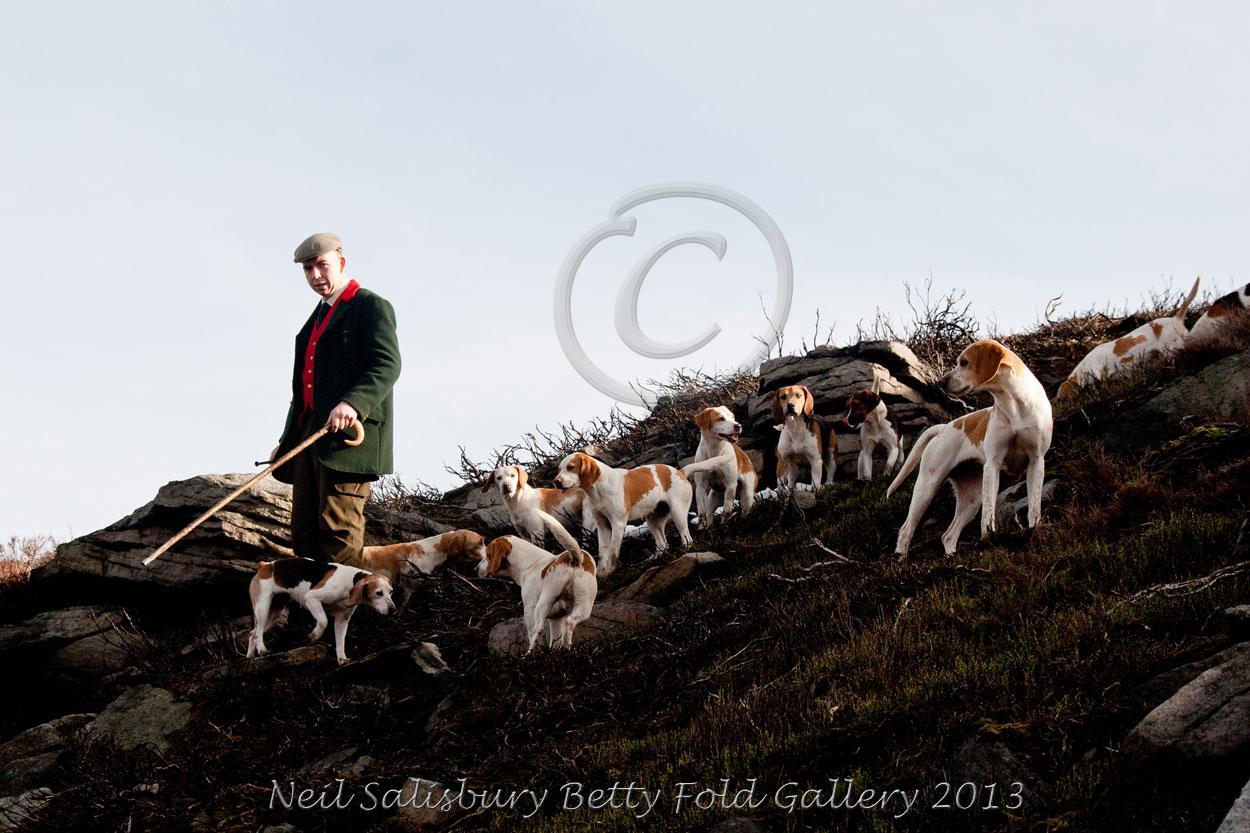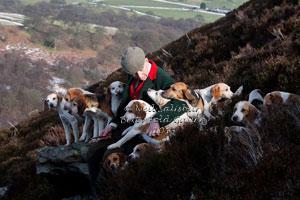The first image is the image on the left, the second image is the image on the right. For the images shown, is this caption "there is exactly one person in the image on the left" true? Answer yes or no. Yes. The first image is the image on the left, the second image is the image on the right. Examine the images to the left and right. Is the description "There are dogs near a vehicle parked on the roadway." accurate? Answer yes or no. No. 